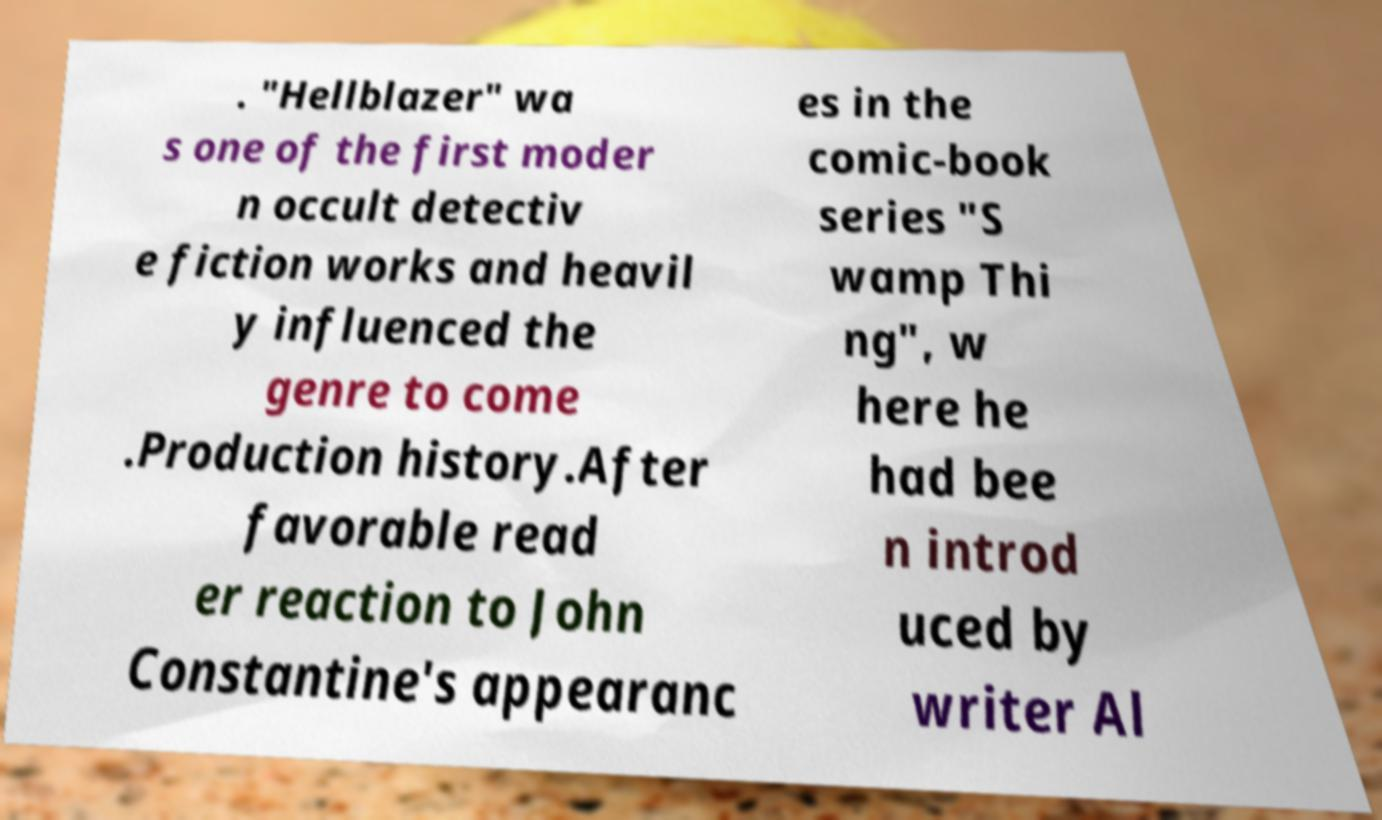There's text embedded in this image that I need extracted. Can you transcribe it verbatim? . "Hellblazer" wa s one of the first moder n occult detectiv e fiction works and heavil y influenced the genre to come .Production history.After favorable read er reaction to John Constantine's appearanc es in the comic-book series "S wamp Thi ng", w here he had bee n introd uced by writer Al 